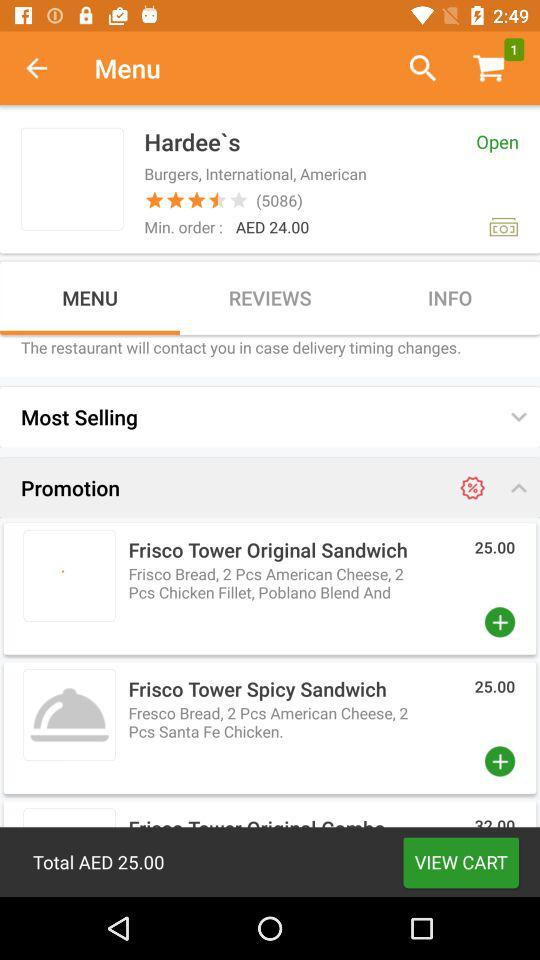Which tab is selected? The selected tab is "MENU". 